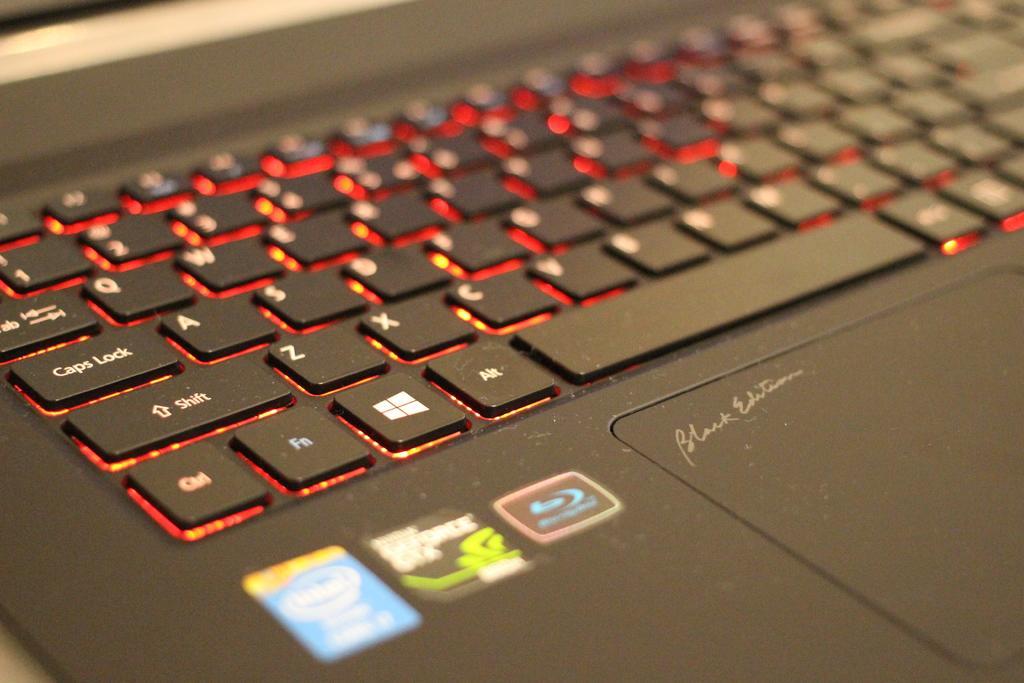Please provide a concise description of this image. In the picture I can see a keyboard of a laptop. On the laptop I can see logo's. The laptop is black in color. 